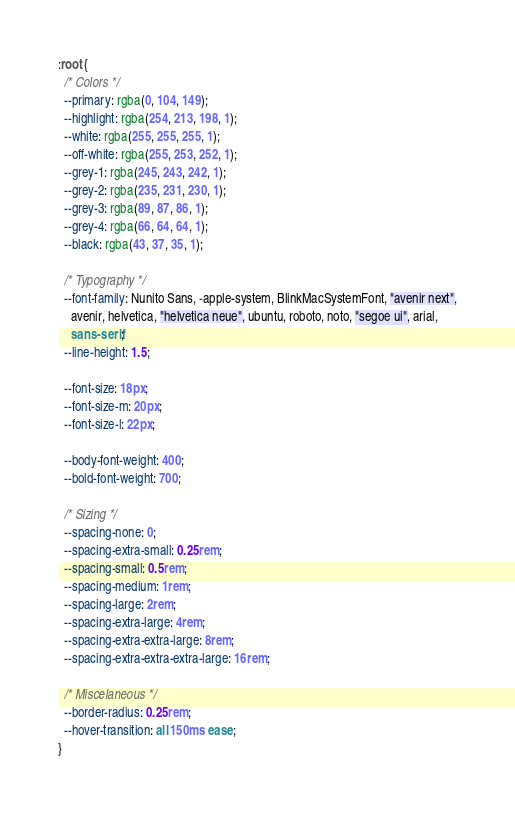Convert code to text. <code><loc_0><loc_0><loc_500><loc_500><_CSS_>:root {
  /* Colors */
  --primary: rgba(0, 104, 149);
  --highlight: rgba(254, 213, 198, 1);
  --white: rgba(255, 255, 255, 1);
  --off-white: rgba(255, 253, 252, 1);
  --grey-1: rgba(245, 243, 242, 1);
  --grey-2: rgba(235, 231, 230, 1);
  --grey-3: rgba(89, 87, 86, 1);
  --grey-4: rgba(66, 64, 64, 1);
  --black: rgba(43, 37, 35, 1);

  /* Typography */
  --font-family: Nunito Sans, -apple-system, BlinkMacSystemFont, "avenir next",
    avenir, helvetica, "helvetica neue", ubuntu, roboto, noto, "segoe ui", arial,
    sans-serif;
  --line-height: 1.5;

  --font-size: 18px;
  --font-size-m: 20px;
  --font-size-l: 22px;

  --body-font-weight: 400;
  --bold-font-weight: 700;

  /* Sizing */
  --spacing-none: 0;
  --spacing-extra-small: 0.25rem;
  --spacing-small: 0.5rem;
  --spacing-medium: 1rem;
  --spacing-large: 2rem;
  --spacing-extra-large: 4rem;
  --spacing-extra-extra-large: 8rem;
  --spacing-extra-extra-extra-large: 16rem;

  /* Miscelaneous */
  --border-radius: 0.25rem;
  --hover-transition: all 150ms ease;
}
</code> 